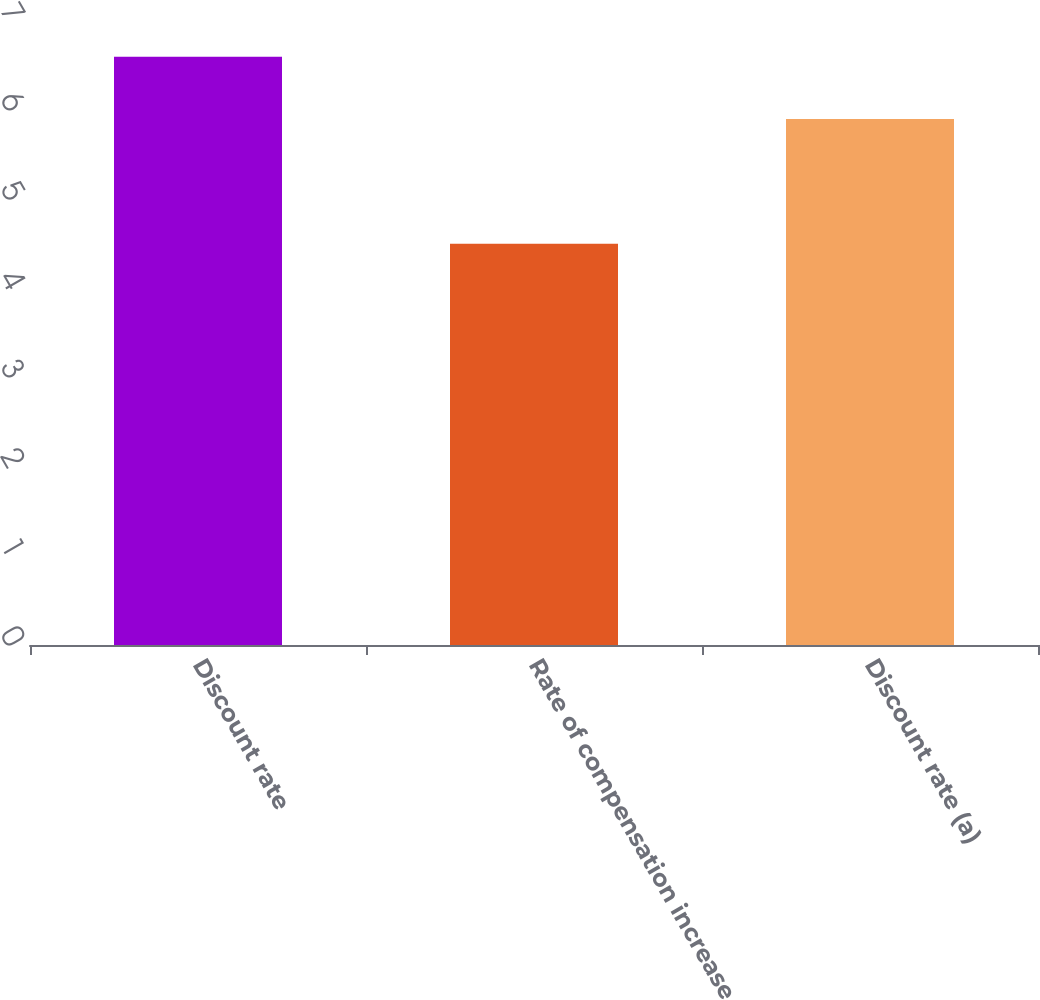Convert chart. <chart><loc_0><loc_0><loc_500><loc_500><bar_chart><fcel>Discount rate<fcel>Rate of compensation increase<fcel>Discount rate (a)<nl><fcel>6.6<fcel>4.5<fcel>5.9<nl></chart> 